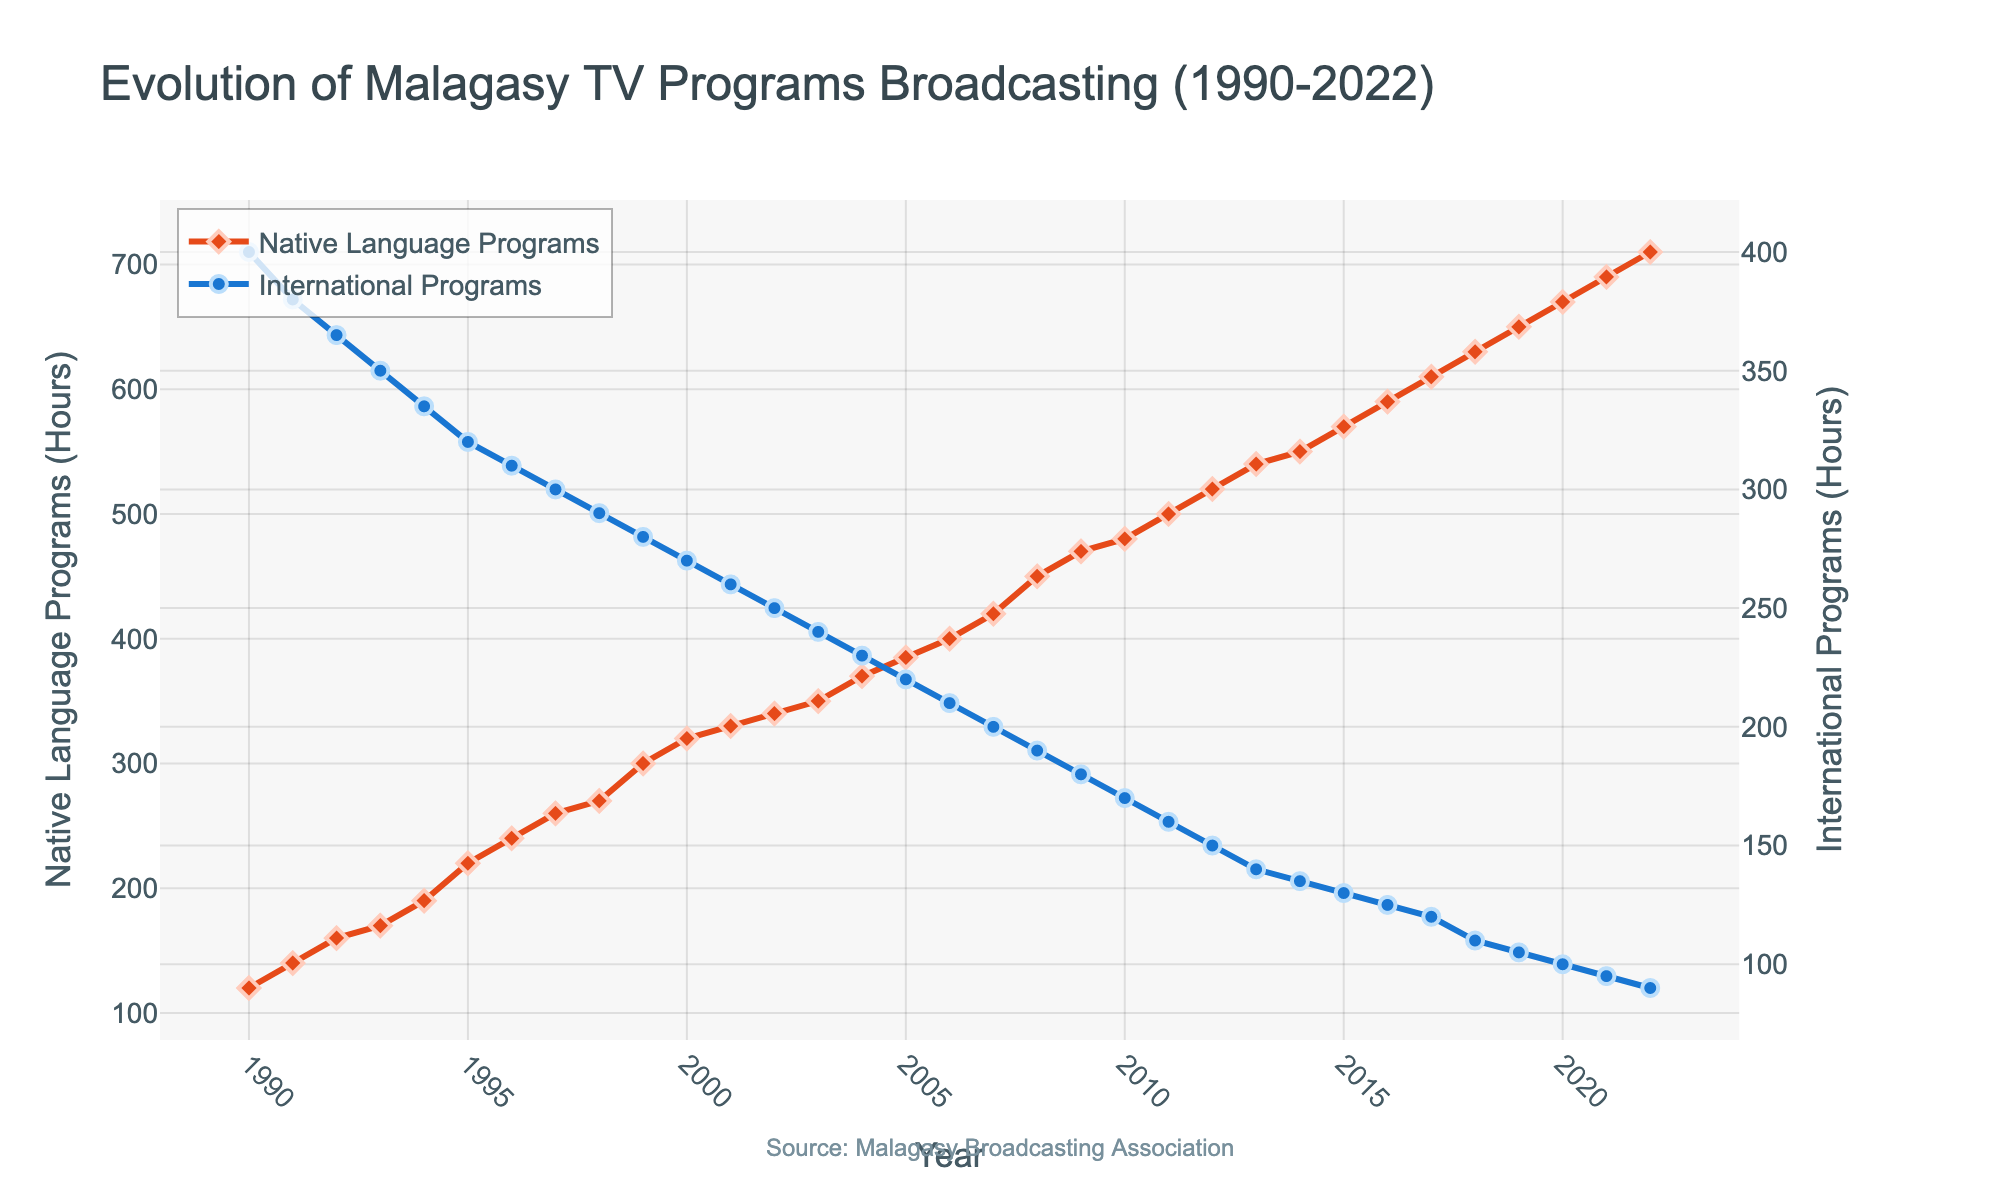What is the overall trend of the Native Language Programs from 1990 to 2022? The overall trend shows a significant increase in the hours of Native Language Programs broadcasted over the years. We start at 120 hours in 1990 and end at 710 hours in 2022, indicating a steady rise.
Answer: Increasing What year had the highest number of hours for International Programs? Locate the peak on the International Programs (blue) line. In 1990, International Programs had 400 hours, which is the highest as the number gradually decreases in the following years.
Answer: 1990 What is the gap between Native Language and International Programs in 2022? For 2022, the Native Language Programs had 710 hours, and International Programs had 90 hours. The difference is 710 - 90 = 620 hours.
Answer: 620 How does the growth of Native Language Programs compare to the decline of International Programs over the three decades? The Native Language Programs steadily increased almost every year from 120 hours in 1990 to 710 hours in 2022. In contrast, International Programs showed a consistent decline from 400 hours in 1990 to 90 hours in 2022. The growth of native language programs is more vigorous and consistent compared to the decline rate of international programs.
Answer: Consistent growth vs. consistent decline What likely year did Native Language Programs surpass International Programs? Look for the year when the Native Language (red) line crosses above the International Programs (blue) line. This occurs between 2005 and 2006.
Answer: 2005 Which type of program shows a more significant fluctuation in the number of hours broadcasted? Both program types exhibit trends, but the International Programs show higher variation yearly due to the sharp decline, while Native Language Programs show a smoother, more gradual increase.
Answer: International Programs How much did the hours of Native Language Programs increase from 2000 to 2010? The hours in 2000 were 320, and in 2010 they were 480. The increase is 480 - 320 = 160 hours.
Answer: 160 By what percentage did International Programs decrease from 1990 to 2022? In 1990, there were 400 hours, and in 2022 there were 90 hours. The decrease is 400 - 90 = 310 hours. The percentage decrease is (310/400) * 100 = 77.5%.
Answer: 77.5% What is the main source of the data used for this figure? This is mentioned in the annotation at the bottom of the figure stating "Source: Malagasy Broadcasting Association".
Answer: Malagasy Broadcasting Association 